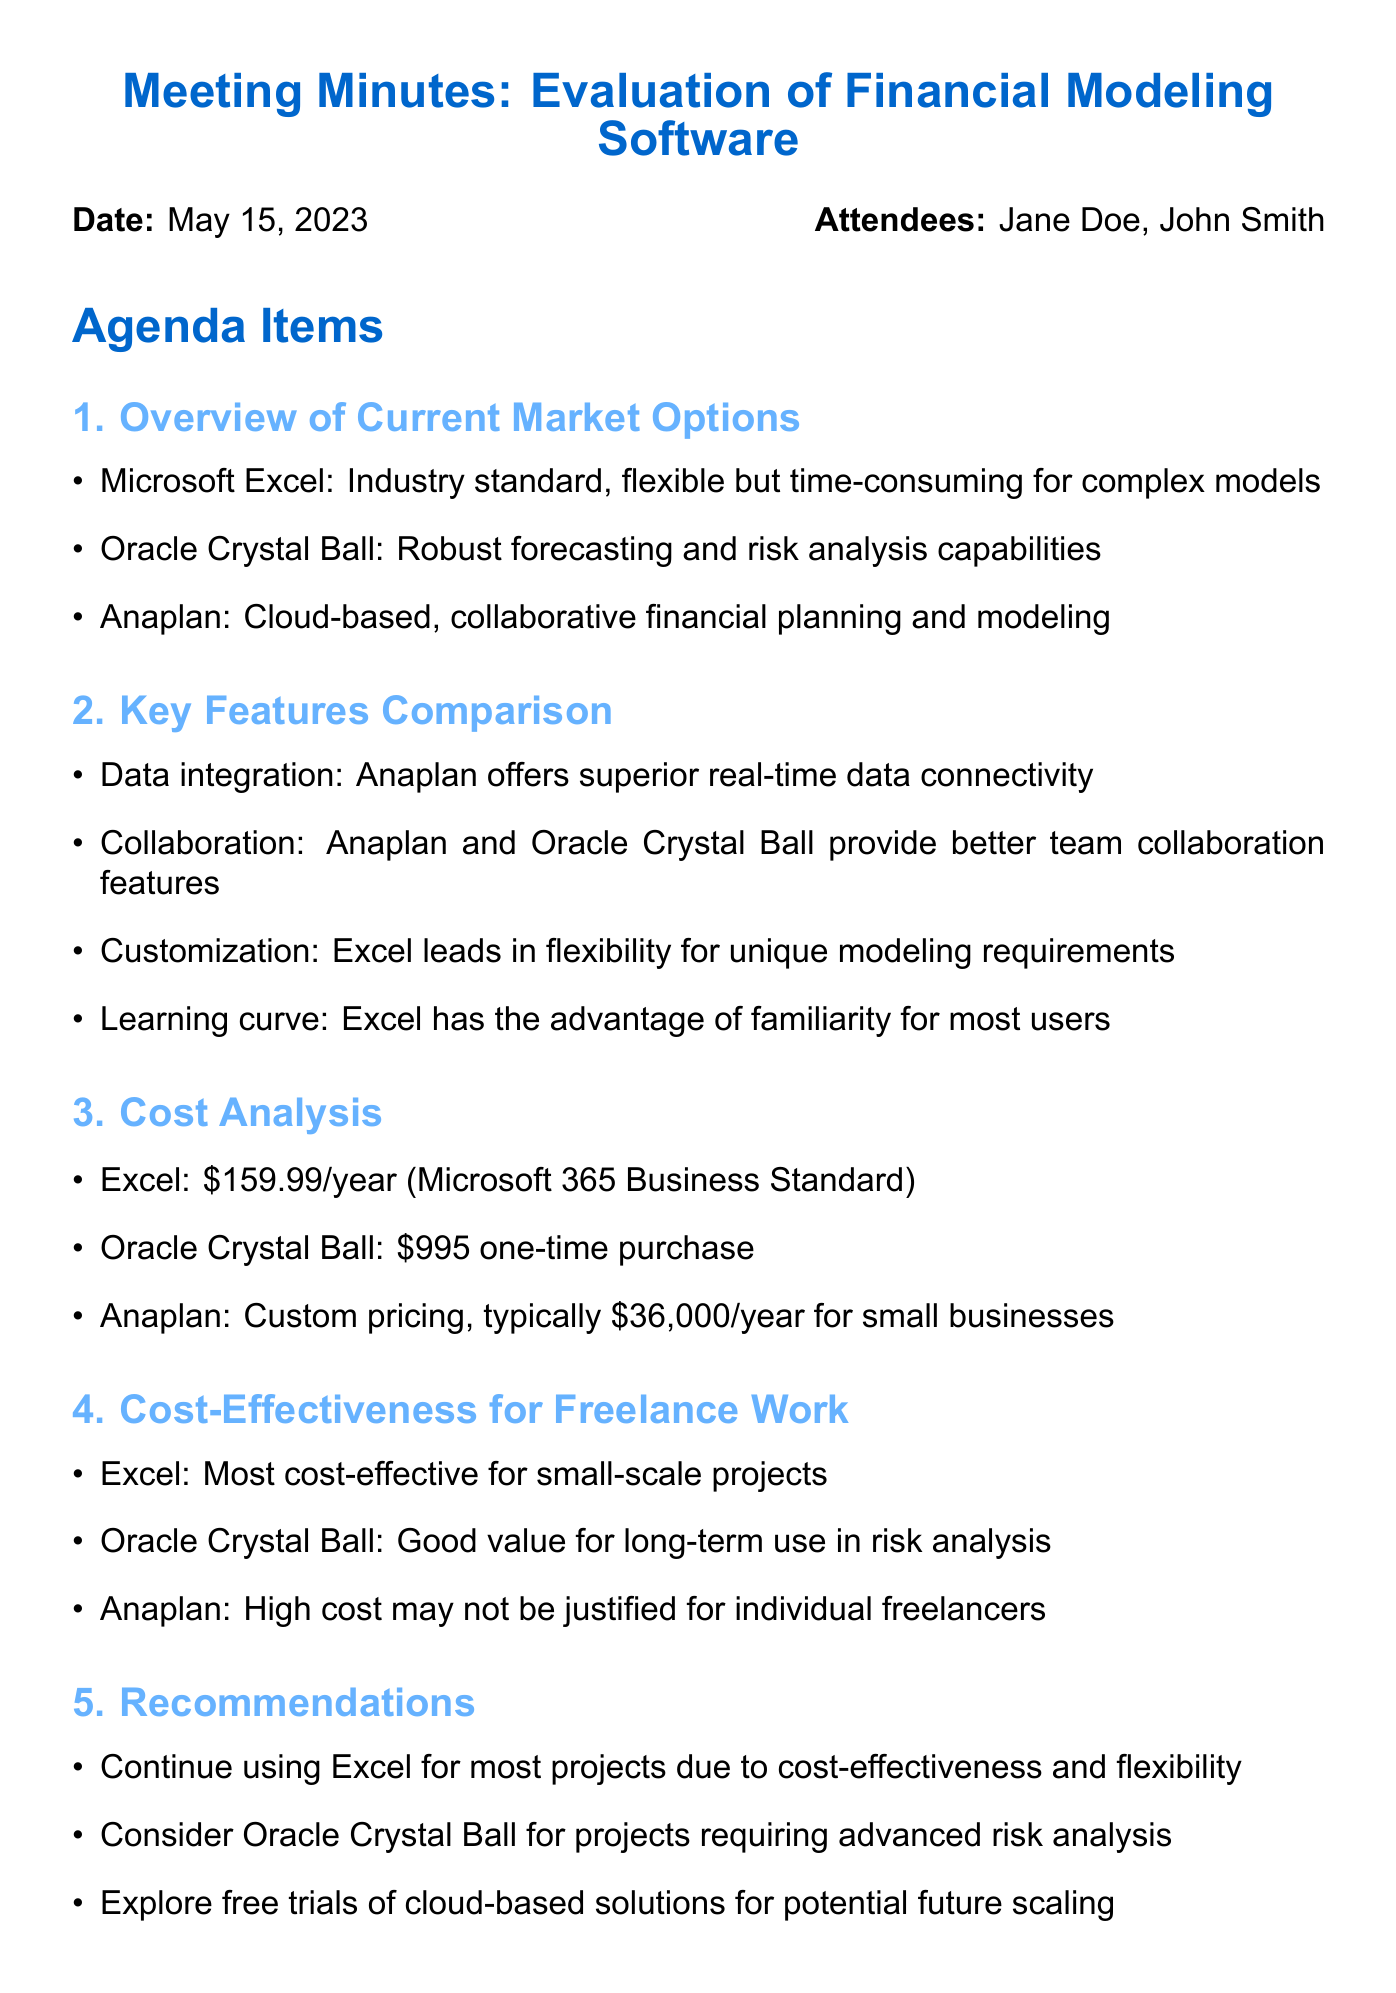What is the date of the meeting? The date of the meeting is mentioned in the document as May 15, 2023.
Answer: May 15, 2023 Who is the author of the document? The attendees include Jane Doe, who is a freelance financial analyst, indicating she is likely the author.
Answer: Jane Doe What is the cost of Microsoft Excel? The document states that Microsoft Excel costs $159.99 per year.
Answer: $159.99/year Which software has the best collaborative features? Anaplan and Oracle Crystal Ball are indicated as providing better team collaboration features.
Answer: Anaplan and Oracle Crystal Ball What is the recommended software for most projects? The recommendations suggest to continue using Excel for most projects due to its cost-effectiveness.
Answer: Excel Which software is a one-time purchase? The document specifies that Oracle Crystal Ball requires a one-time purchase.
Answer: Oracle Crystal Ball What action is recommended regarding cloud-based solutions? The minutes suggest exploring free trials of cloud-based solutions for potential future scaling.
Answer: Explore free trials Identify the primary focus of the meeting? The meeting focused on evaluating new financial modeling software options for freelance work.
Answer: Evaluation of Financial Modeling Software What is the price range for Anaplan? The document indicates that Anaplan typically costs $36,000 per year for small businesses.
Answer: $36,000/year 